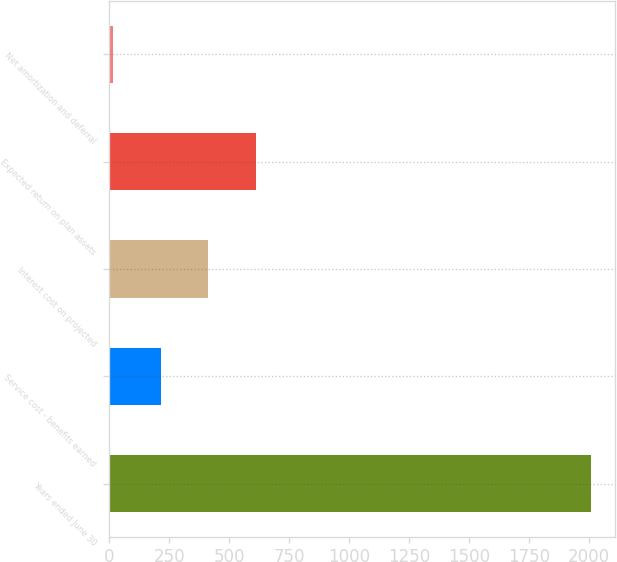<chart> <loc_0><loc_0><loc_500><loc_500><bar_chart><fcel>Years ended June 30<fcel>Service cost - benefits earned<fcel>Interest cost on projected<fcel>Expected return on plan assets<fcel>Net amortization and deferral<nl><fcel>2007<fcel>213.84<fcel>413.08<fcel>612.32<fcel>14.6<nl></chart> 